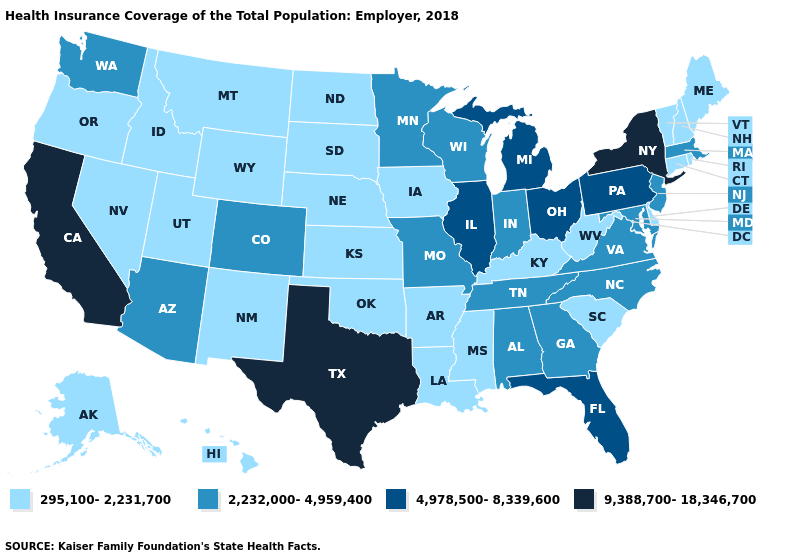What is the value of Mississippi?
Quick response, please. 295,100-2,231,700. Name the states that have a value in the range 2,232,000-4,959,400?
Concise answer only. Alabama, Arizona, Colorado, Georgia, Indiana, Maryland, Massachusetts, Minnesota, Missouri, New Jersey, North Carolina, Tennessee, Virginia, Washington, Wisconsin. What is the lowest value in the West?
Quick response, please. 295,100-2,231,700. Name the states that have a value in the range 2,232,000-4,959,400?
Answer briefly. Alabama, Arizona, Colorado, Georgia, Indiana, Maryland, Massachusetts, Minnesota, Missouri, New Jersey, North Carolina, Tennessee, Virginia, Washington, Wisconsin. Does the map have missing data?
Concise answer only. No. Name the states that have a value in the range 9,388,700-18,346,700?
Concise answer only. California, New York, Texas. What is the lowest value in the USA?
Write a very short answer. 295,100-2,231,700. Which states have the lowest value in the Northeast?
Answer briefly. Connecticut, Maine, New Hampshire, Rhode Island, Vermont. Which states have the highest value in the USA?
Keep it brief. California, New York, Texas. Name the states that have a value in the range 295,100-2,231,700?
Write a very short answer. Alaska, Arkansas, Connecticut, Delaware, Hawaii, Idaho, Iowa, Kansas, Kentucky, Louisiana, Maine, Mississippi, Montana, Nebraska, Nevada, New Hampshire, New Mexico, North Dakota, Oklahoma, Oregon, Rhode Island, South Carolina, South Dakota, Utah, Vermont, West Virginia, Wyoming. What is the value of Iowa?
Give a very brief answer. 295,100-2,231,700. Does Alaska have a lower value than Illinois?
Short answer required. Yes. How many symbols are there in the legend?
Short answer required. 4. Which states have the lowest value in the USA?
Short answer required. Alaska, Arkansas, Connecticut, Delaware, Hawaii, Idaho, Iowa, Kansas, Kentucky, Louisiana, Maine, Mississippi, Montana, Nebraska, Nevada, New Hampshire, New Mexico, North Dakota, Oklahoma, Oregon, Rhode Island, South Carolina, South Dakota, Utah, Vermont, West Virginia, Wyoming. What is the value of Mississippi?
Keep it brief. 295,100-2,231,700. 